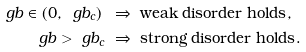Convert formula to latex. <formula><loc_0><loc_0><loc_500><loc_500>\ g b \in ( 0 , \ g b _ { c } ) \ & \Rightarrow \text { weak disorder holds} , \\ \ g b > \ g b _ { c } \ & \Rightarrow \text { strong disorder holds} .</formula> 